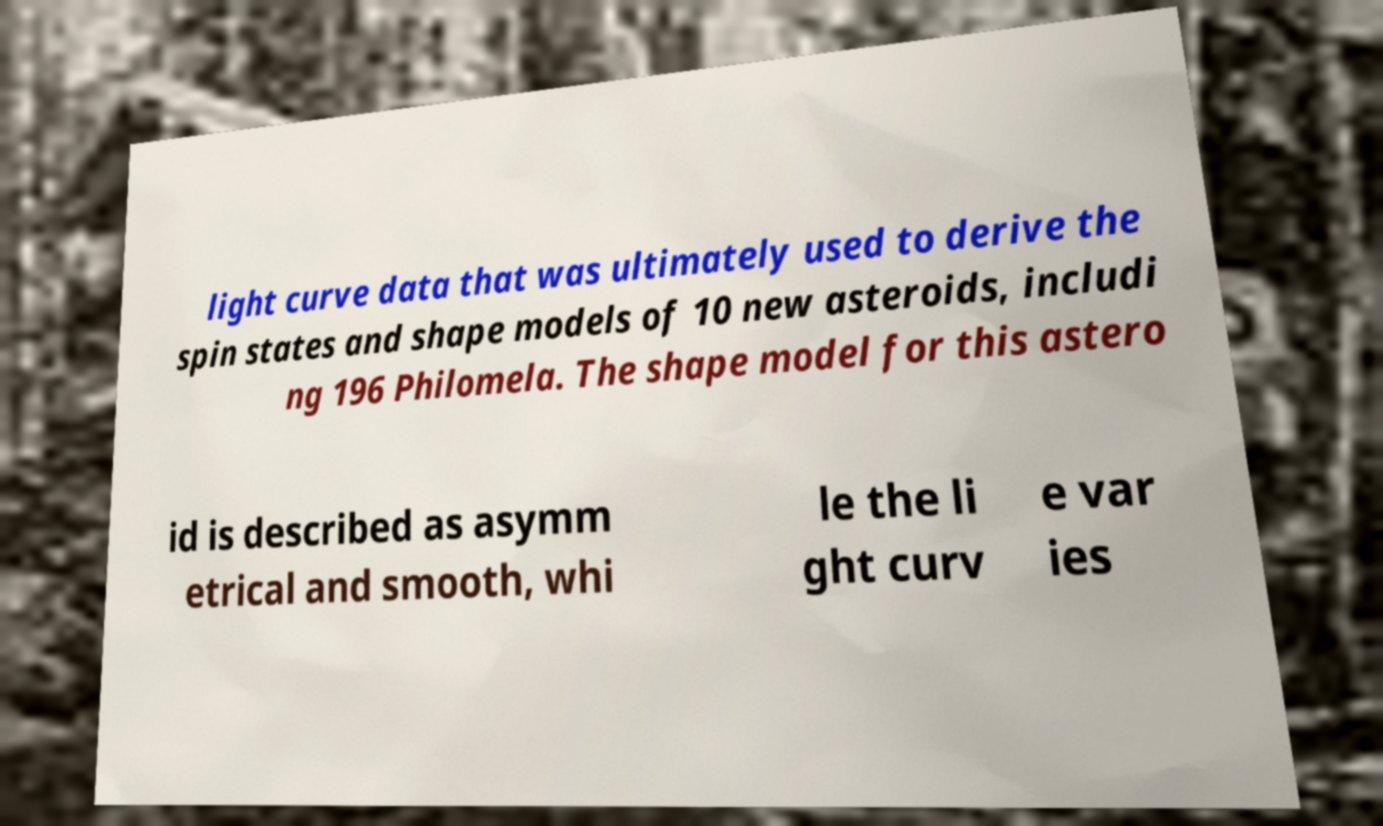What messages or text are displayed in this image? I need them in a readable, typed format. light curve data that was ultimately used to derive the spin states and shape models of 10 new asteroids, includi ng 196 Philomela. The shape model for this astero id is described as asymm etrical and smooth, whi le the li ght curv e var ies 